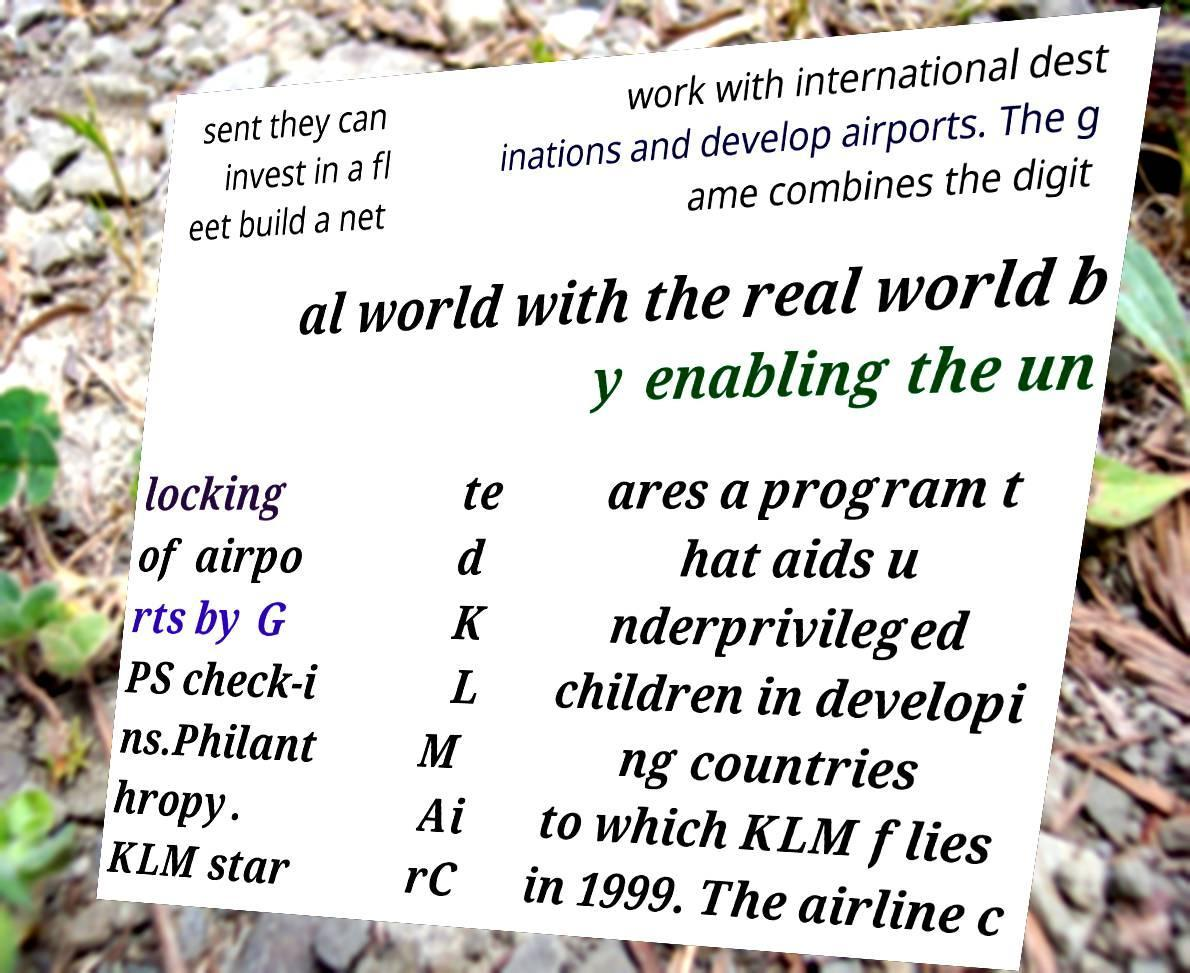Could you extract and type out the text from this image? sent they can invest in a fl eet build a net work with international dest inations and develop airports. The g ame combines the digit al world with the real world b y enabling the un locking of airpo rts by G PS check-i ns.Philant hropy. KLM star te d K L M Ai rC ares a program t hat aids u nderprivileged children in developi ng countries to which KLM flies in 1999. The airline c 